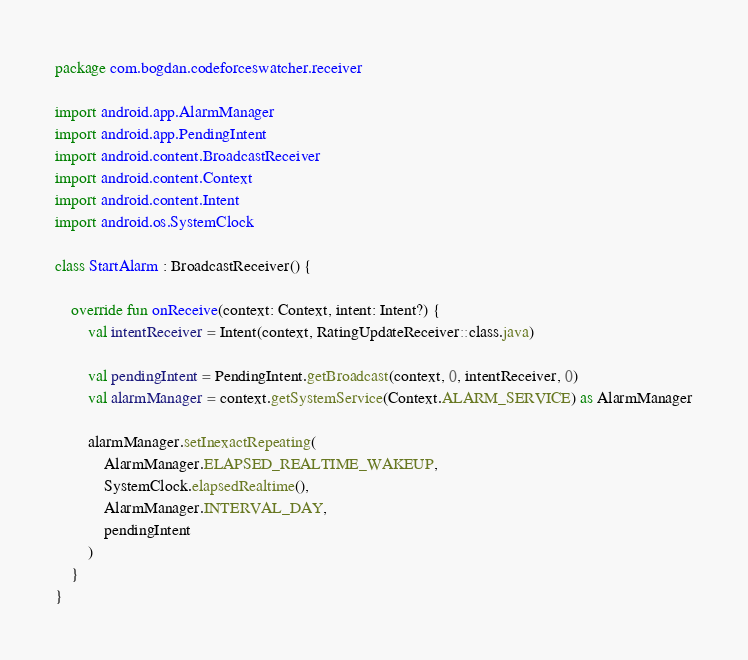Convert code to text. <code><loc_0><loc_0><loc_500><loc_500><_Kotlin_>package com.bogdan.codeforceswatcher.receiver

import android.app.AlarmManager
import android.app.PendingIntent
import android.content.BroadcastReceiver
import android.content.Context
import android.content.Intent
import android.os.SystemClock

class StartAlarm : BroadcastReceiver() {

    override fun onReceive(context: Context, intent: Intent?) {
        val intentReceiver = Intent(context, RatingUpdateReceiver::class.java)

        val pendingIntent = PendingIntent.getBroadcast(context, 0, intentReceiver, 0)
        val alarmManager = context.getSystemService(Context.ALARM_SERVICE) as AlarmManager

        alarmManager.setInexactRepeating(
            AlarmManager.ELAPSED_REALTIME_WAKEUP,
            SystemClock.elapsedRealtime(),
            AlarmManager.INTERVAL_DAY,
            pendingIntent
        )
    }
}
</code> 